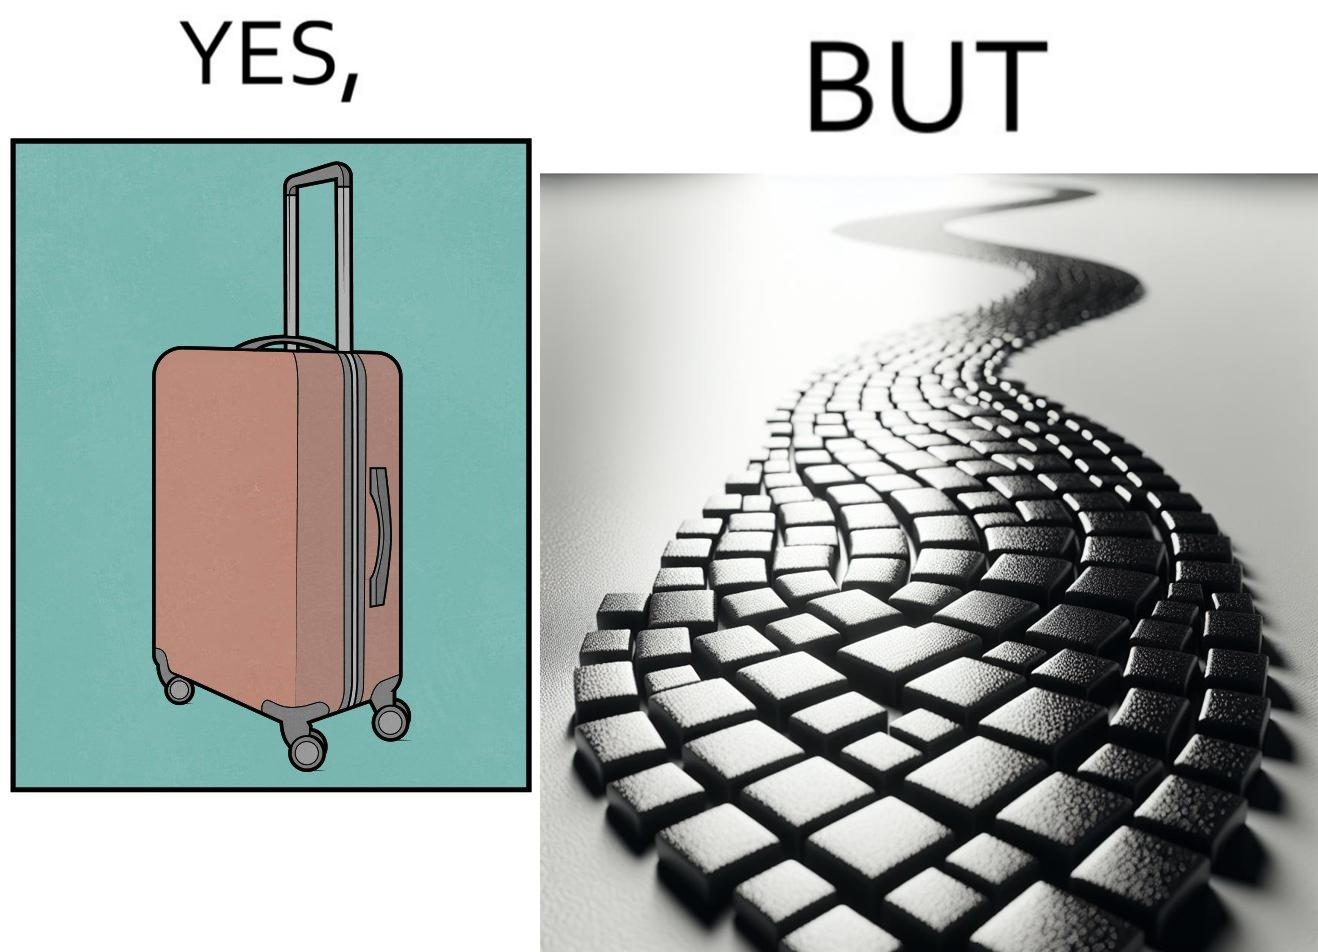What does this image depict? The image is funny because even though the trolley bag is made to make carrying luggage easy, as soon as it encounters a rough surface like cobblestone road, it makes carrying luggage more difficult. 